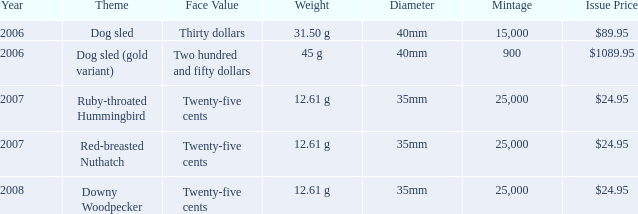What motif is featured on the $89.95 coin? Dog sled. 